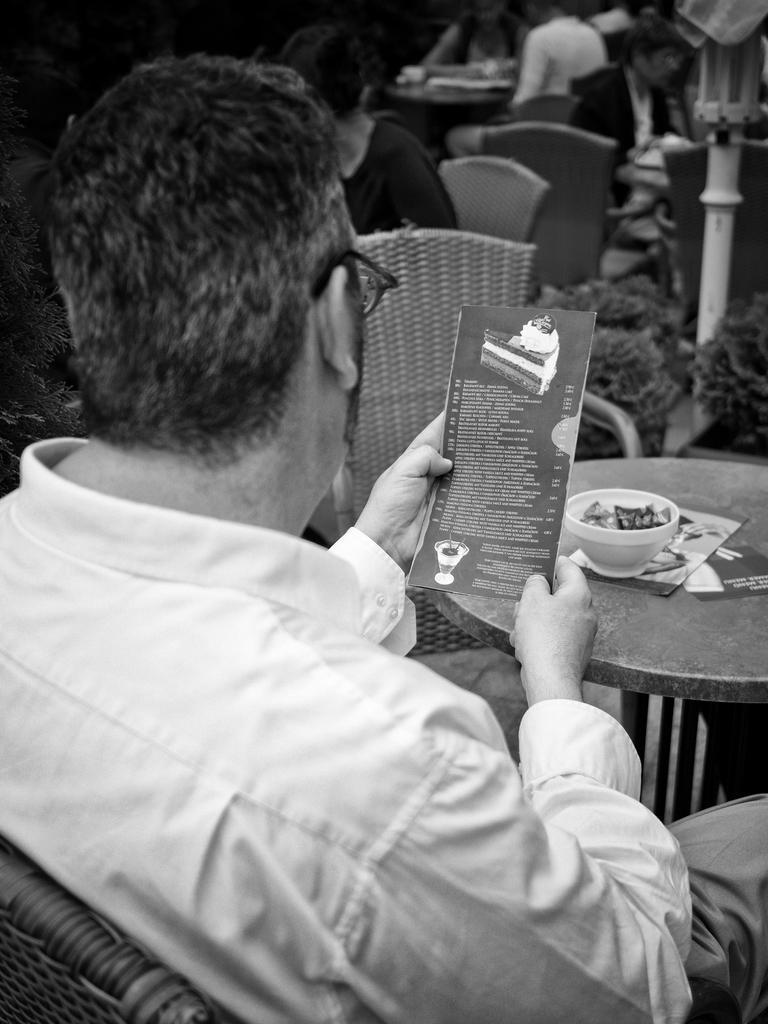Can you describe this image briefly? In this image there is a man sitting in chair and looking at the menu card. There is a table in front of him on which there is a bowl full of food. At the background there are other people who are sitting in the chair. 